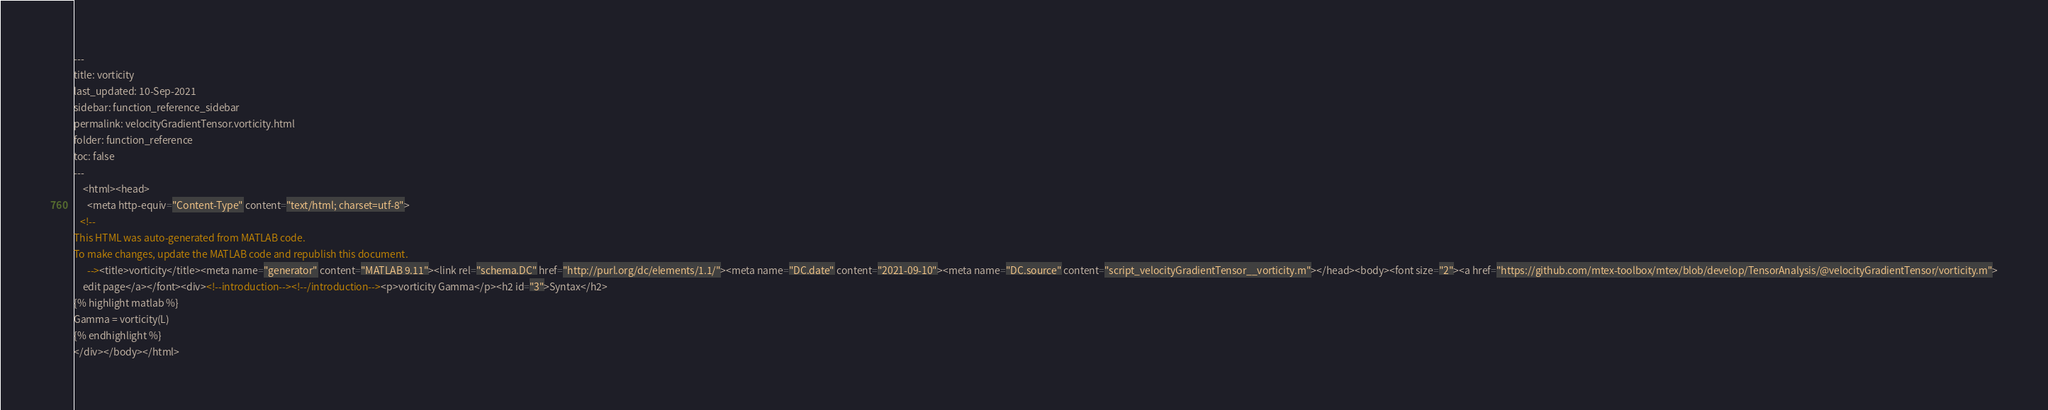Convert code to text. <code><loc_0><loc_0><loc_500><loc_500><_HTML_>---
title: vorticity
last_updated: 10-Sep-2021
sidebar: function_reference_sidebar
permalink: velocityGradientTensor.vorticity.html
folder: function_reference
toc: false
---
    <html><head>
      <meta http-equiv="Content-Type" content="text/html; charset=utf-8">
   <!--
This HTML was auto-generated from MATLAB code.
To make changes, update the MATLAB code and republish this document.
      --><title>vorticity</title><meta name="generator" content="MATLAB 9.11"><link rel="schema.DC" href="http://purl.org/dc/elements/1.1/"><meta name="DC.date" content="2021-09-10"><meta name="DC.source" content="script_velocityGradientTensor__vorticity.m"></head><body><font size="2"><a href="https://github.com/mtex-toolbox/mtex/blob/develop/TensorAnalysis/@velocityGradientTensor/vorticity.m">
    edit page</a></font><div><!--introduction--><!--/introduction--><p>vorticity Gamma</p><h2 id="3">Syntax</h2>
{% highlight matlab %}
Gamma = vorticity(L)
{% endhighlight %}
</div></body></html></code> 